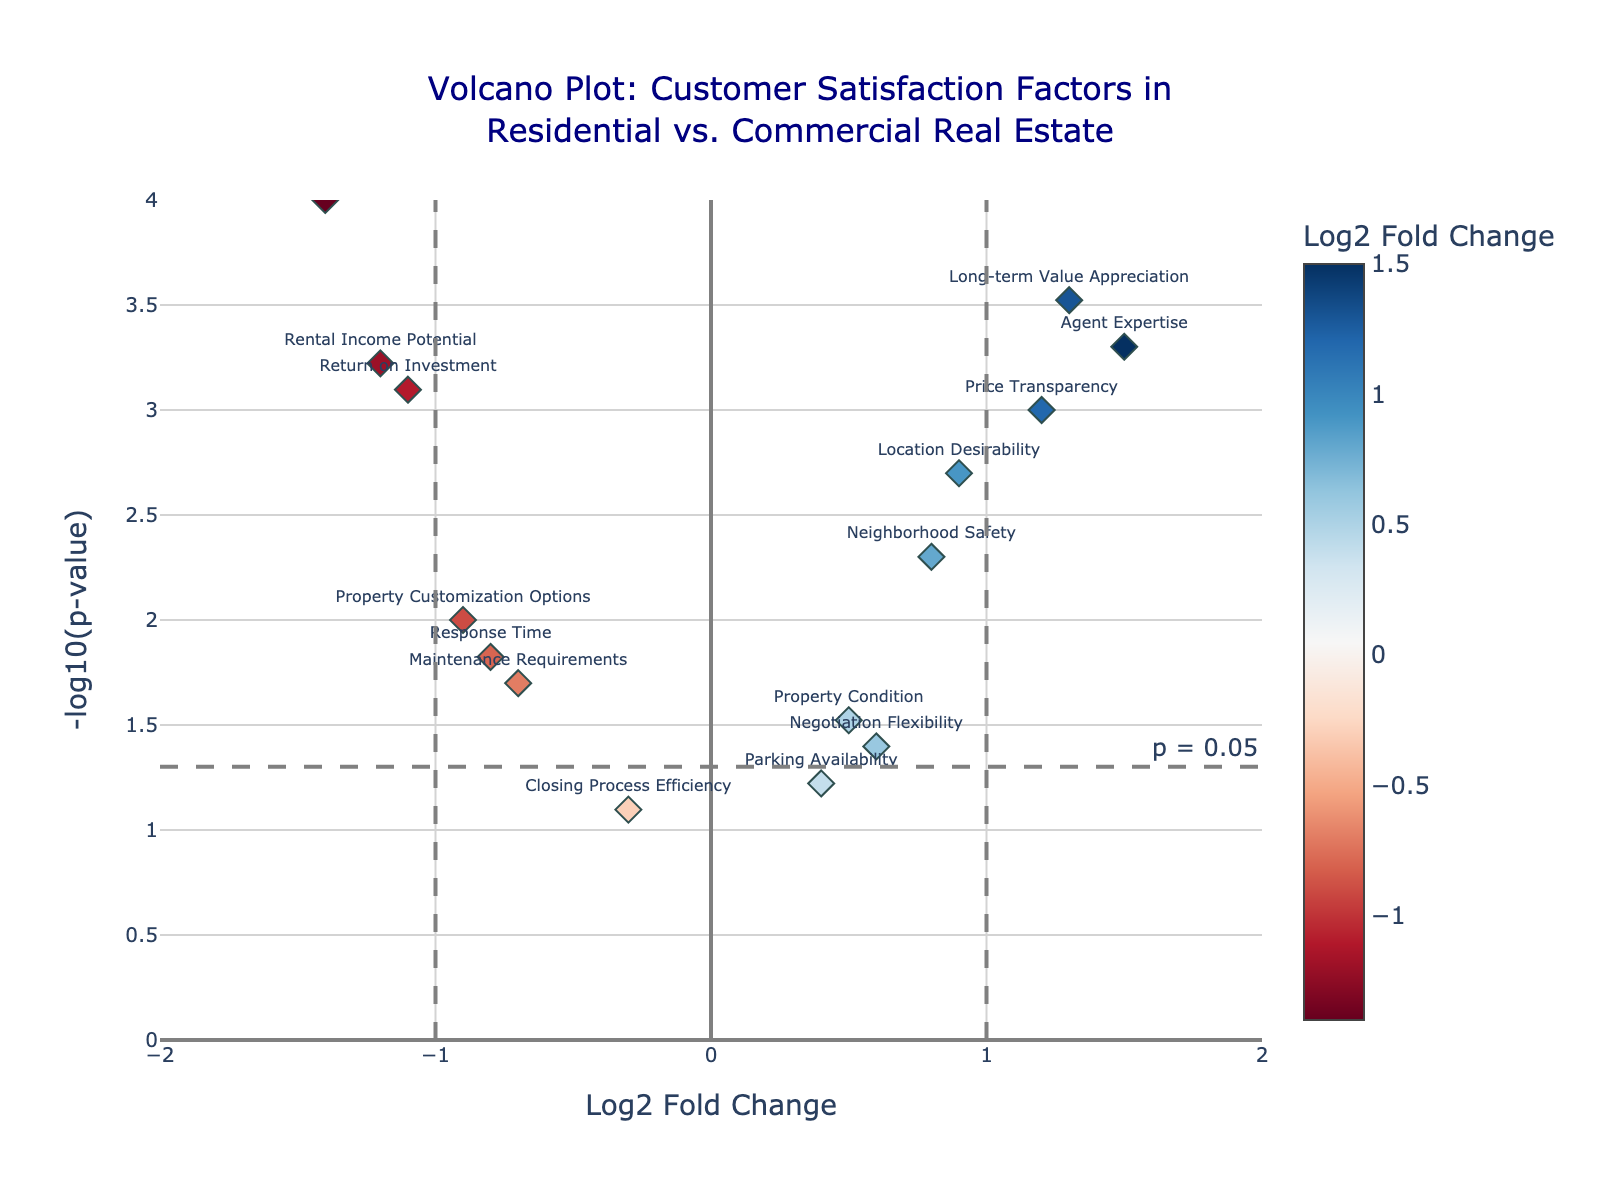What's the title of the figure? The title is usually located at the top of the figure and describes what the plot is about.
Answer: Volcano Plot: Customer Satisfaction Factors in Residential vs. Commercial Real Estate What is the significance threshold for the p-value in the plot? The significance threshold for the p-value is represented by a horizontal dashed line and is annotated as "p = 0.05."
Answer: p = 0.05 Which customer satisfaction factor has the highest positive log-fold change? The log-fold change is represented on the x-axis. The factor with the highest positive log-fold change is the one furthest to the right.
Answer: Agent Expertise Which factor has the lowest p-value? The p-value is represented on the y-axis, with lower p-values higher up. The factor closest to the top of the plot has the lowest p-value.
Answer: Lease Terms Complexity How many factors have a log-fold change greater than 1? Scan the x-axis for factors with a LogFoldChange greater than 1, which is to the right of the solid vertical line at x=1.
Answer: 3 Compare the LogFoldChange values for 'Price Transparency' and 'Response Time'. Which is higher? Locate the points for 'Price Transparency' and 'Response Time' on the x-axis and compare their LogFoldChange values.
Answer: Price Transparency What is the -log10(p-value) for 'Long-term Value Appreciation'? Find the marker for 'Long-term Value Appreciation' and trace it to the y-axis to determine the -log10(p-value).
Answer: ~3.52 Which factors have a negative log-fold change and are statistically significant? Look at factors with negative x-axis values and y-axis values above the p=0.05 threshold line. These factors are both statistically significant and have a negative log-fold change.
Answer: Response Time, Lease Terms Complexity, Return on Investment, Rental Income Potential, Maintenance Requirements, Property Customization Options Is 'Neighborhood Safety' considered statistically significant? Check if the point for 'Neighborhood Safety' is above the p=0.05 threshold line. If it's above the line, it is statistically significant.
Answer: Yes 